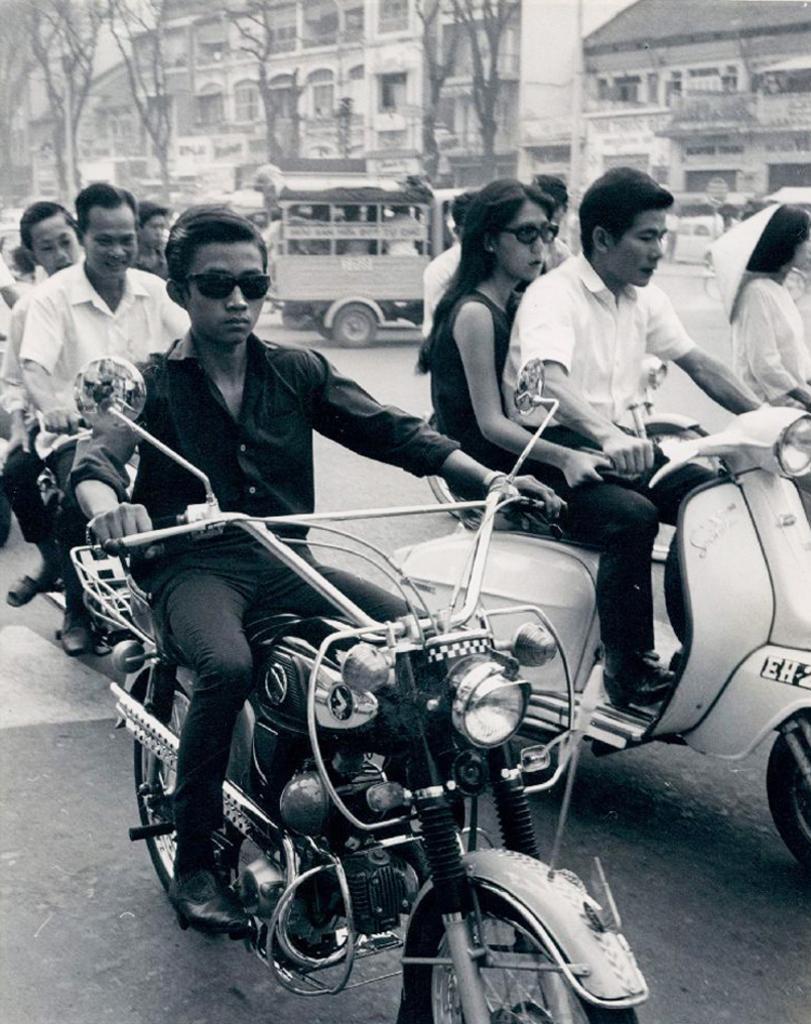Could you give a brief overview of what you see in this image? This is a picture taken outside a city. There are many people riding motor vehicles in the foreground of the image. In the center of the image there is a truck. In the background there are buildings, trees. 